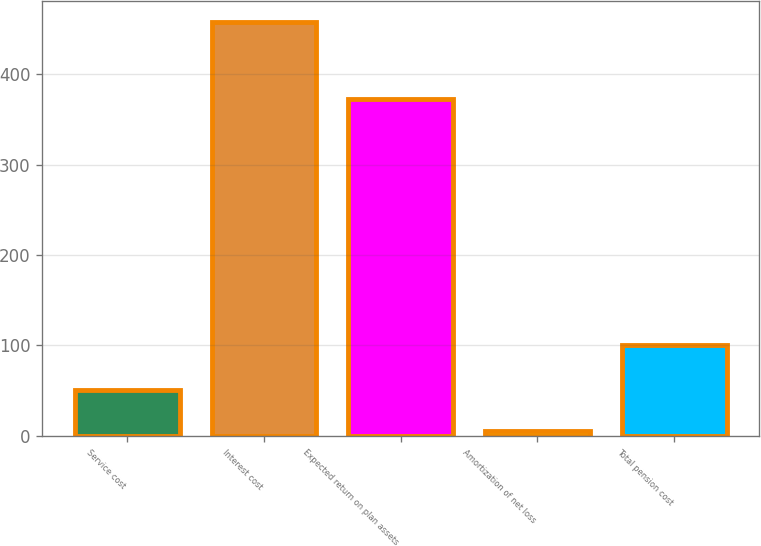Convert chart. <chart><loc_0><loc_0><loc_500><loc_500><bar_chart><fcel>Service cost<fcel>Interest cost<fcel>Expected return on plan assets<fcel>Amortization of net loss<fcel>Total pension cost<nl><fcel>51.2<fcel>458<fcel>373<fcel>6<fcel>101<nl></chart> 